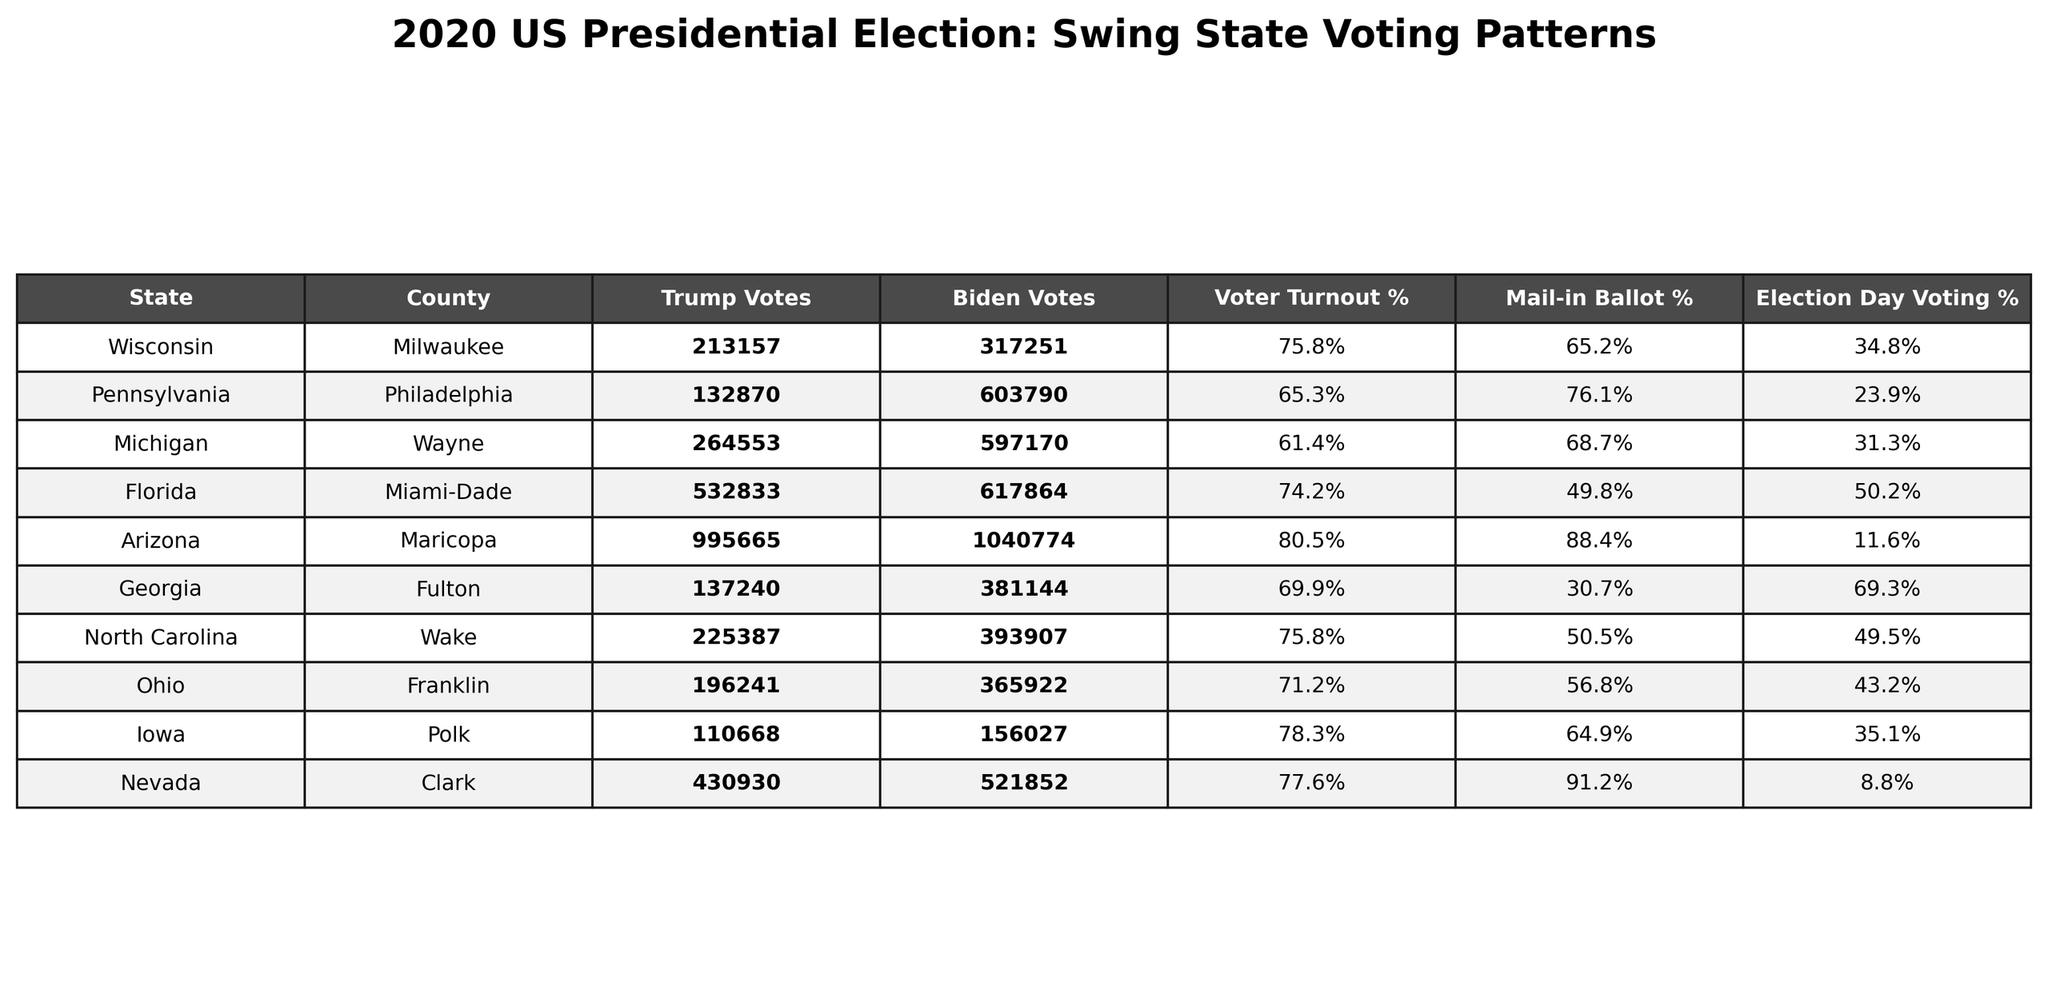What state had the highest voter turnout percentage? By examining the "Voter Turnout %" column, we can identify that Wisconsin has the highest voter turnout percentage of 75.8%.
Answer: 75.8% How many votes did Donald Trump receive in Arizona? The table shows that Donald Trump received 995,665 votes in Arizona, as indicated in the "Trump Votes" column.
Answer: 995665 What is the difference in votes between Biden and Trump in Michigan? To calculate the difference, we subtract Trump votes (264,553) from Biden votes (597,170): 597,170 - 264,553 = 332,617.
Answer: 332617 Which state had the lowest percentage of mail-in ballots for voting? By inspecting the "Mail-in Ballot %" column, we find that Miami-Dade in Florida had the lowest percentage at 49.8%.
Answer: 49.8% Is it true that Pennsylvania had more Biden votes than Trump votes? Yes, by comparing the votes, Biden received 603,790 votes while Trump received only 132,870, confirming Biden's lead.
Answer: Yes What is the average voter turnout percentage across all the states listed in the table? Adding the voter turnout percentages (75.8 + 65.3 + 61.4 + 74.2 + 80.5 + 69.9 + 75.8 + 71.2 + 78.3 + 77.6) results in 760.6. Dividing by the number of states (10) gives an average of 76.06%.
Answer: 76.06% Which county had the highest number of votes for Biden? By examining the "Biden Votes" column, we see that Philadelphia had the highest total with 603,790 votes for Biden.
Answer: 603790 In which state did Election Day voting account for the majority of votes? Analyzing the "Election Day Voting %" column, we see that Florida (50.2%) had Election Day voting account for a slightly higher proportion compared to other states.
Answer: Florida What percentage of the votes in Georgia were cast through mail-in ballots? For Georgia, the table indicates that 30.7% of the votes were cast through mail-in ballots, as highlighted in the "Mail-in Ballot %" column.
Answer: 30.7% How many more votes did Biden receive in Clark County compared to Trump? Biden received 521,852 votes and Trump received 430,930 votes in Clark County. The difference is 521,852 - 430,930 = 90,922.
Answer: 90922 Which county had the lowest voter turnout percentage? By reviewing the "Voter Turnout %" column, we find that Philadelphia in Pennsylvania had the lowest turnout at 65.3%.
Answer: 65.3% 